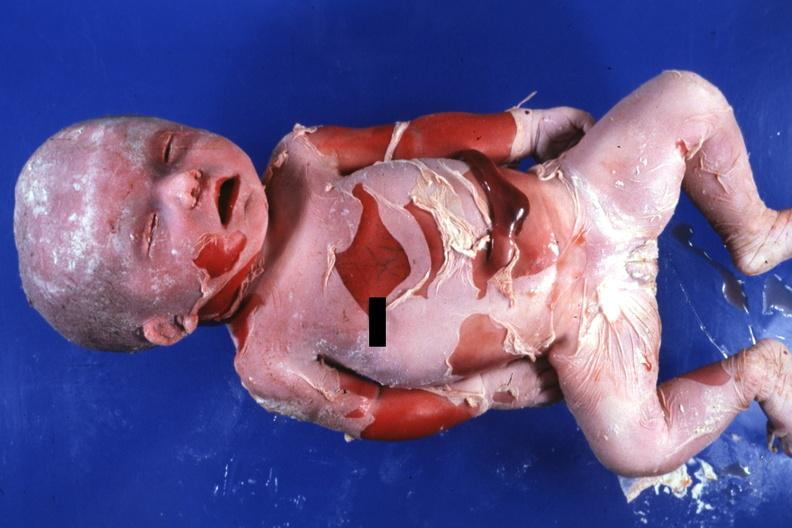does acute peritonitis show natural color advanced typical?
Answer the question using a single word or phrase. No 